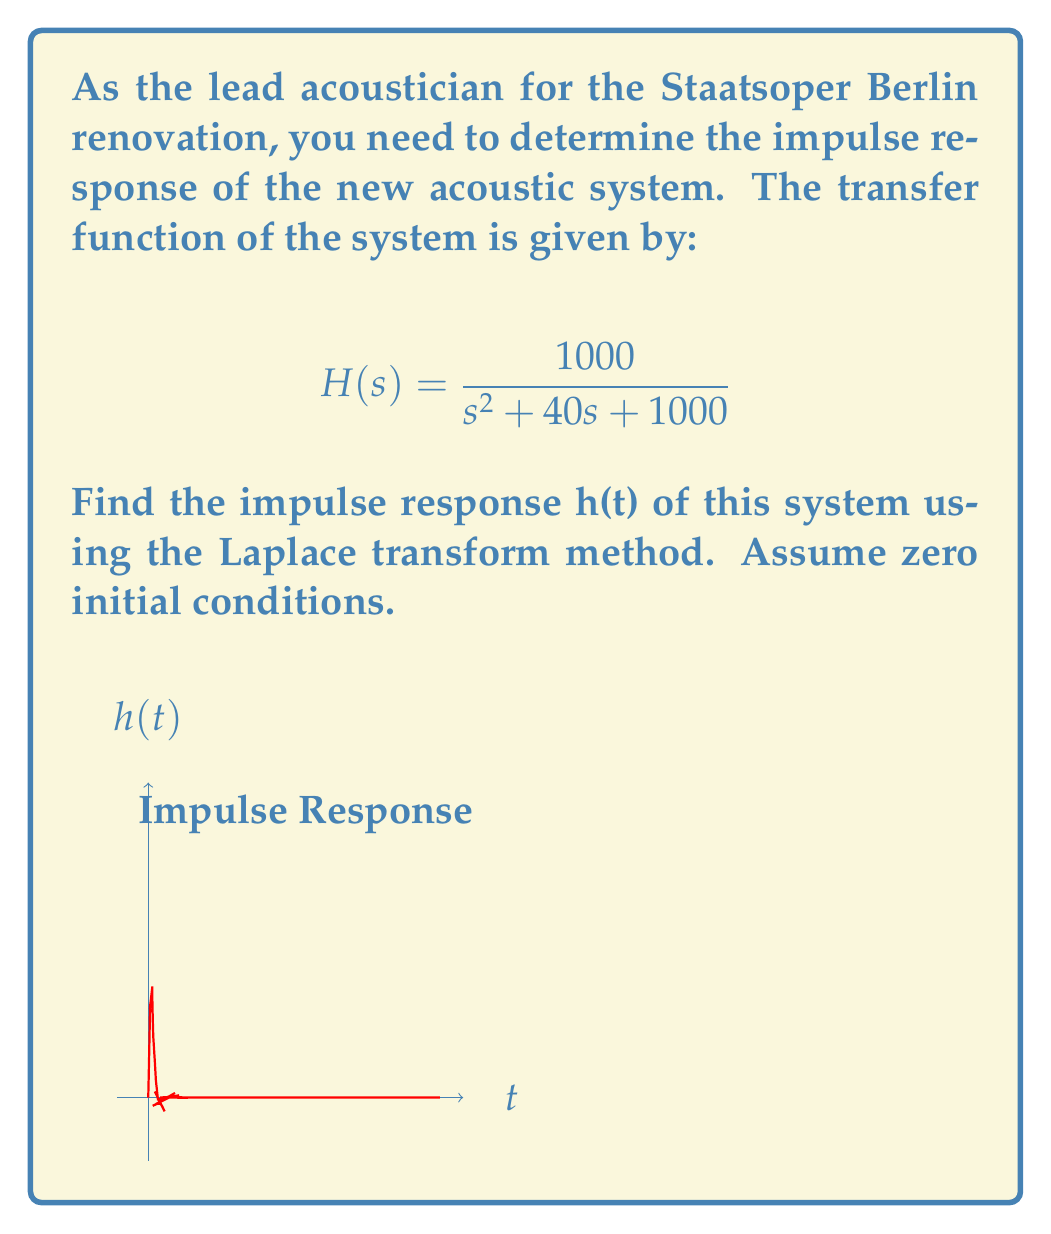Can you solve this math problem? To find the impulse response h(t), we need to take the inverse Laplace transform of H(s). Let's proceed step-by-step:

1) We start with the given transfer function:
   $$H(s) = \frac{1000}{s^2 + 40s + 1000}$$

2) To find the inverse Laplace transform, we need to put H(s) in a standard form. Let's complete the square in the denominator:
   $$s^2 + 40s + 1000 = (s + 20)^2 + 600$$

3) Now we can rewrite H(s) as:
   $$H(s) = \frac{1000}{(s + 20)^2 + 600}$$

4) This is in the standard form for the inverse Laplace transform of a damped sinusoidal function:
   $$\mathcal{L}^{-1}\left\{\frac{\omega_n^2}{(s + \alpha)^2 + \omega^2}\right\} = e^{-\alpha t} \frac{\sin(\omega t)}{\omega}$$

   Where in our case:
   $\omega_n^2 = 1000$, $\alpha = 20$, and $\omega^2 = 600$

5) Therefore, $\omega = \sqrt{600} \approx 24.49$

6) Applying the inverse Laplace transform:
   $$h(t) = \frac{1000}{\sqrt{600}} e^{-20t} \sin(\sqrt{600}t)$$

7) Simplifying:
   $$h(t) = \frac{1000}{\sqrt{600}} e^{-20t} \sin(24.49t)$$
   $$h(t) \approx 40.82 e^{-20t} \sin(24.49t)$$

This function represents the impulse response of the acoustic system.
Answer: $h(t) \approx 40.82 e^{-20t} \sin(24.49t)$ 